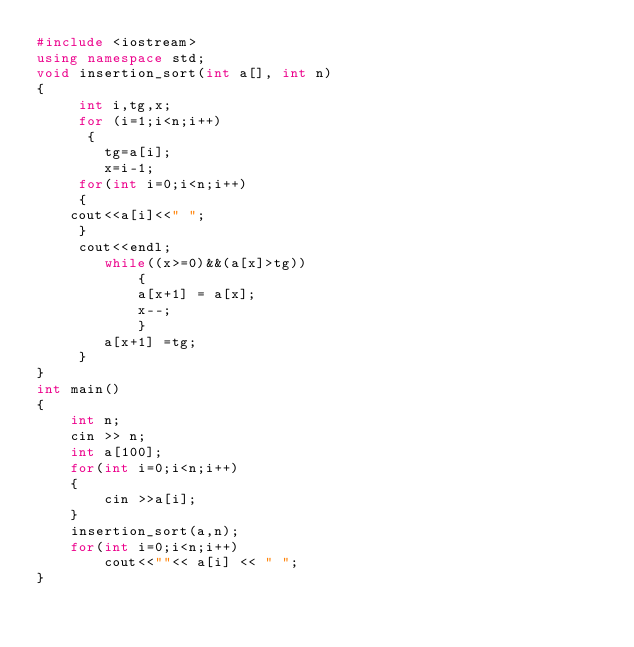Convert code to text. <code><loc_0><loc_0><loc_500><loc_500><_C++_>#include <iostream>
using namespace std;
void insertion_sort(int a[], int n)
{ 
     int i,tg,x;
     for (i=1;i<n;i++)
      {
        tg=a[i];
        x=i-1;	
     for(int i=0;i<n;i++)
     {
	cout<<a[i]<<" ";
     }
     cout<<endl;
        while((x>=0)&&(a[x]>tg))
            {
            a[x+1] = a[x]; 
            x--; 
            }
        a[x+1] =tg;
     }
}
int main()
{
    int n;
    cin >> n;
    int a[100];
    for(int i=0;i<n;i++)
    {
        cin >>a[i];
    }
    insertion_sort(a,n);
    for(int i=0;i<n;i++)
        cout<<""<< a[i] << " ";
}</code> 